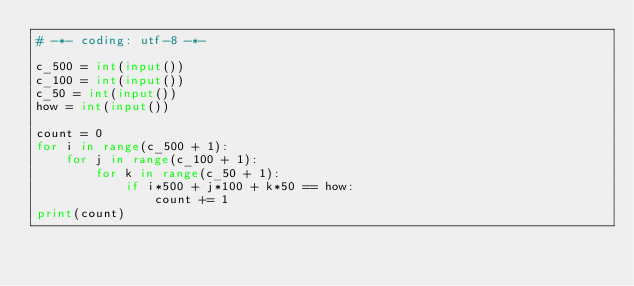<code> <loc_0><loc_0><loc_500><loc_500><_Python_># -*- coding: utf-8 -*-

c_500 = int(input())
c_100 = int(input())
c_50 = int(input())
how = int(input())

count = 0
for i in range(c_500 + 1):
    for j in range(c_100 + 1):
        for k in range(c_50 + 1):
            if i*500 + j*100 + k*50 == how:
                count += 1
print(count)</code> 